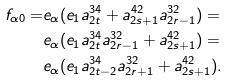<formula> <loc_0><loc_0><loc_500><loc_500>f _ { \alpha 0 } = & e _ { \alpha } ( e _ { 1 } { a } ^ { 3 4 } _ { 2 t } + a ^ { 4 2 } _ { 2 s + 1 } { a } ^ { 3 2 } _ { 2 r - 1 } ) = \\ & e _ { \alpha } ( e _ { 1 } { a } ^ { 3 4 } _ { 2 t } { a } ^ { 3 2 } _ { 2 r - 1 } + a ^ { 4 2 } _ { 2 s + 1 } ) = \\ & e _ { \alpha } ( e _ { 1 } { a } ^ { 3 4 } _ { 2 t - 2 } { a } ^ { 3 2 } _ { 2 r + 1 } + a ^ { 4 2 } _ { 2 s + 1 } ) .</formula> 